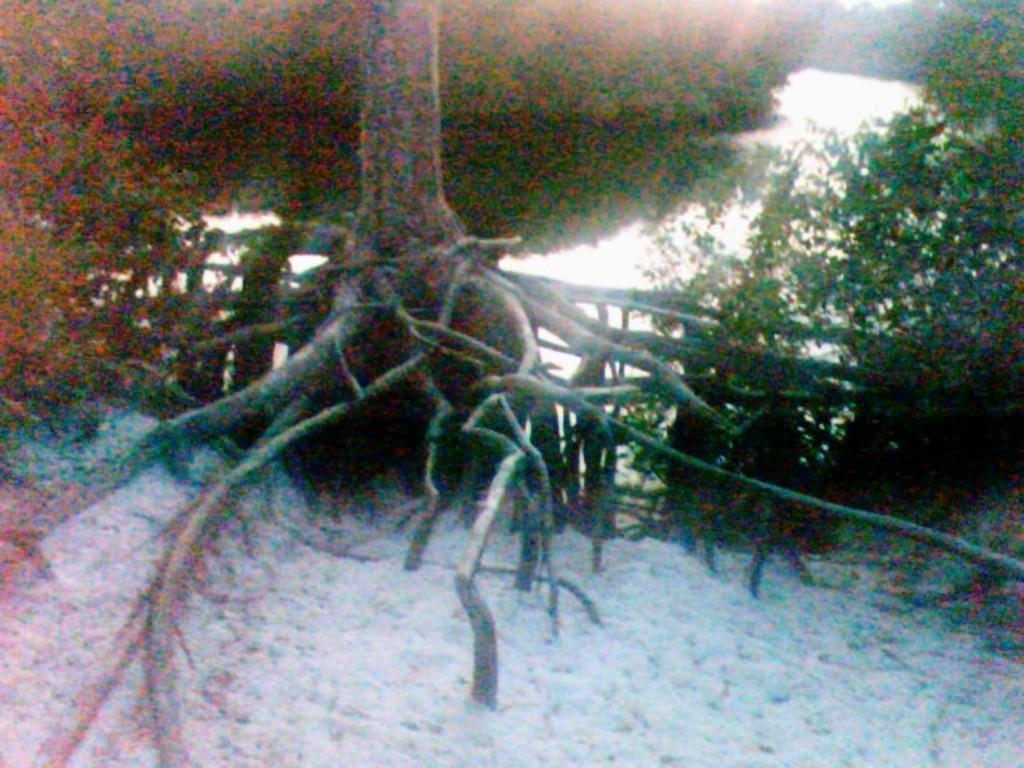In one or two sentences, can you explain what this image depicts? In this image at the bottom there is snow, and in the background there are some trees and roots of a tree. 